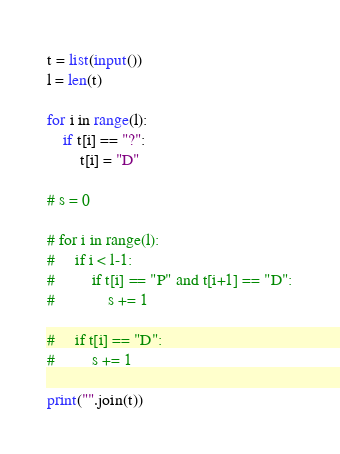Convert code to text. <code><loc_0><loc_0><loc_500><loc_500><_Python_>t = list(input())
l = len(t)

for i in range(l):
    if t[i] == "?":
        t[i] = "D"

# s = 0

# for i in range(l):
#     if i < l-1:
#         if t[i] == "P" and t[i+1] == "D":
#             s += 1
    
#     if t[i] == "D":
#         s += 1

print("".join(t))</code> 